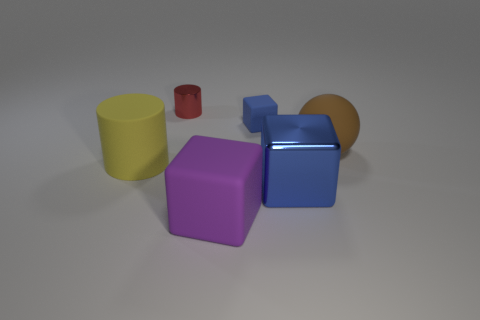Subtract all blue spheres. Subtract all yellow blocks. How many spheres are left? 1 Add 3 large objects. How many objects exist? 9 Subtract all balls. How many objects are left? 5 Subtract 1 brown balls. How many objects are left? 5 Subtract all large matte objects. Subtract all large brown things. How many objects are left? 2 Add 4 purple rubber cubes. How many purple rubber cubes are left? 5 Add 5 tiny brown cylinders. How many tiny brown cylinders exist? 5 